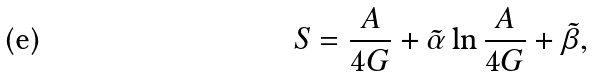Convert formula to latex. <formula><loc_0><loc_0><loc_500><loc_500>S = \frac { A } { 4 G } + \tilde { \alpha } \ln { \frac { A } { 4 G } } + \tilde { \beta } ,</formula> 